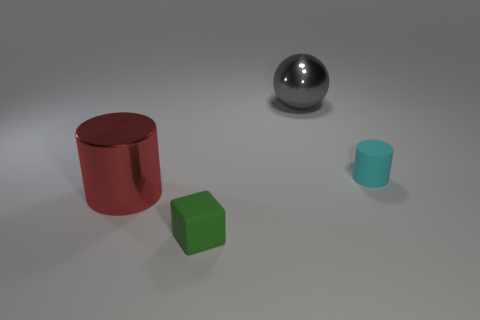What is the material of the cyan cylinder that is the same size as the green rubber cube?
Your answer should be compact. Rubber. How many other things are there of the same material as the tiny cyan cylinder?
Your response must be concise. 1. There is a tiny object that is on the right side of the sphere; does it have the same shape as the small object to the left of the large gray ball?
Provide a succinct answer. No. The big shiny thing that is behind the small rubber cylinder that is in front of the large object on the right side of the green matte cube is what color?
Give a very brief answer. Gray. Is the number of metallic objects less than the number of tiny cyan matte blocks?
Offer a terse response. No. There is a object that is in front of the gray metallic object and right of the green matte object; what color is it?
Make the answer very short. Cyan. There is a red object that is the same shape as the cyan object; what is its material?
Keep it short and to the point. Metal. Is there any other thing that is the same size as the green cube?
Offer a very short reply. Yes. Are there more tiny green blocks than metal things?
Your response must be concise. No. What is the size of the thing that is to the right of the small cube and in front of the large gray object?
Make the answer very short. Small. 